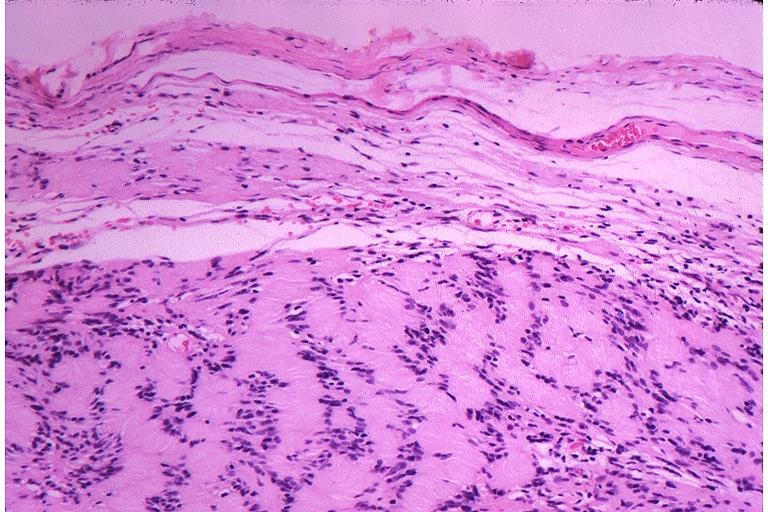does this image show schwanoma neurilemoma?
Answer the question using a single word or phrase. Yes 